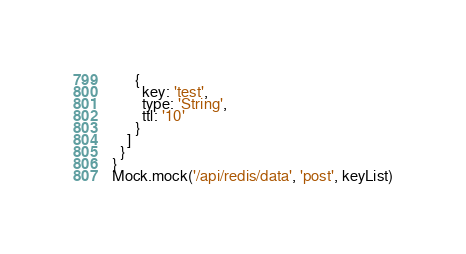<code> <loc_0><loc_0><loc_500><loc_500><_JavaScript_>      {
        key: 'test',
        type: 'String',
        ttl: '10'
      }
    ]
  }
}
Mock.mock('/api/redis/data', 'post', keyList)

</code> 